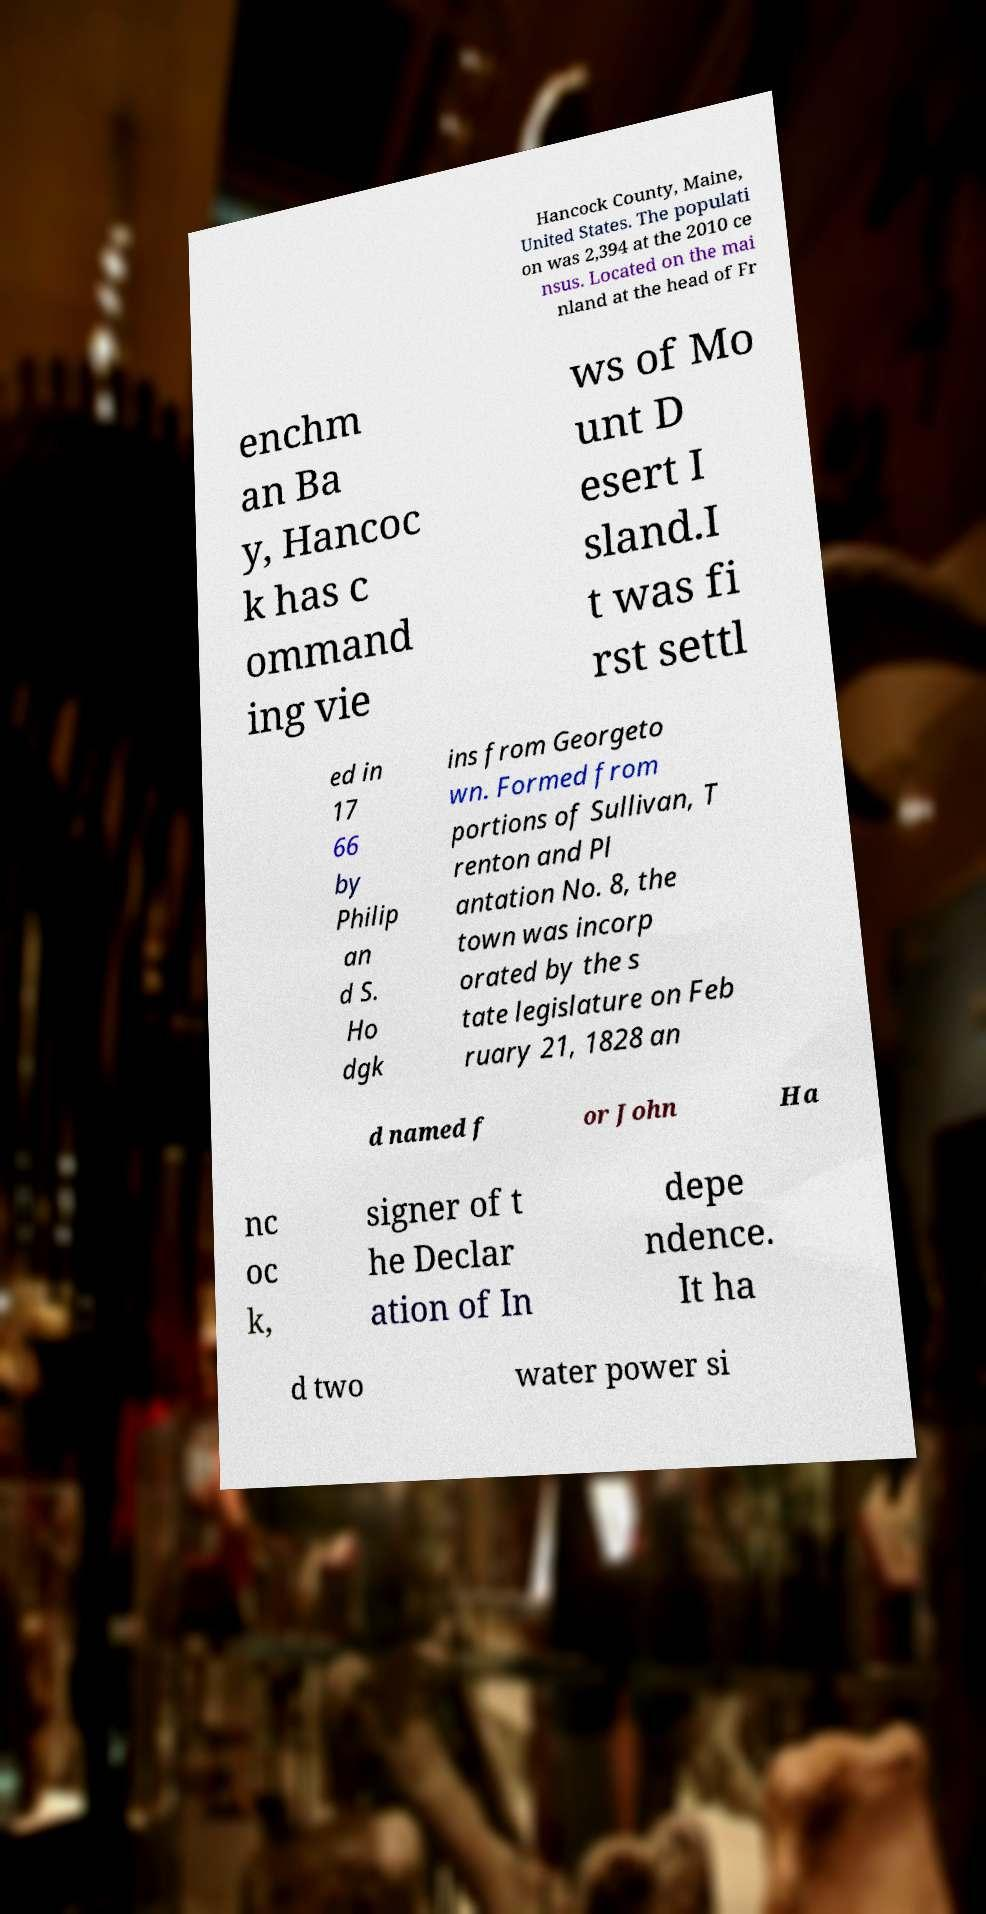Can you accurately transcribe the text from the provided image for me? Hancock County, Maine, United States. The populati on was 2,394 at the 2010 ce nsus. Located on the mai nland at the head of Fr enchm an Ba y, Hancoc k has c ommand ing vie ws of Mo unt D esert I sland.I t was fi rst settl ed in 17 66 by Philip an d S. Ho dgk ins from Georgeto wn. Formed from portions of Sullivan, T renton and Pl antation No. 8, the town was incorp orated by the s tate legislature on Feb ruary 21, 1828 an d named f or John Ha nc oc k, signer of t he Declar ation of In depe ndence. It ha d two water power si 